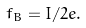Convert formula to latex. <formula><loc_0><loc_0><loc_500><loc_500>f _ { B } = I / 2 e .</formula> 